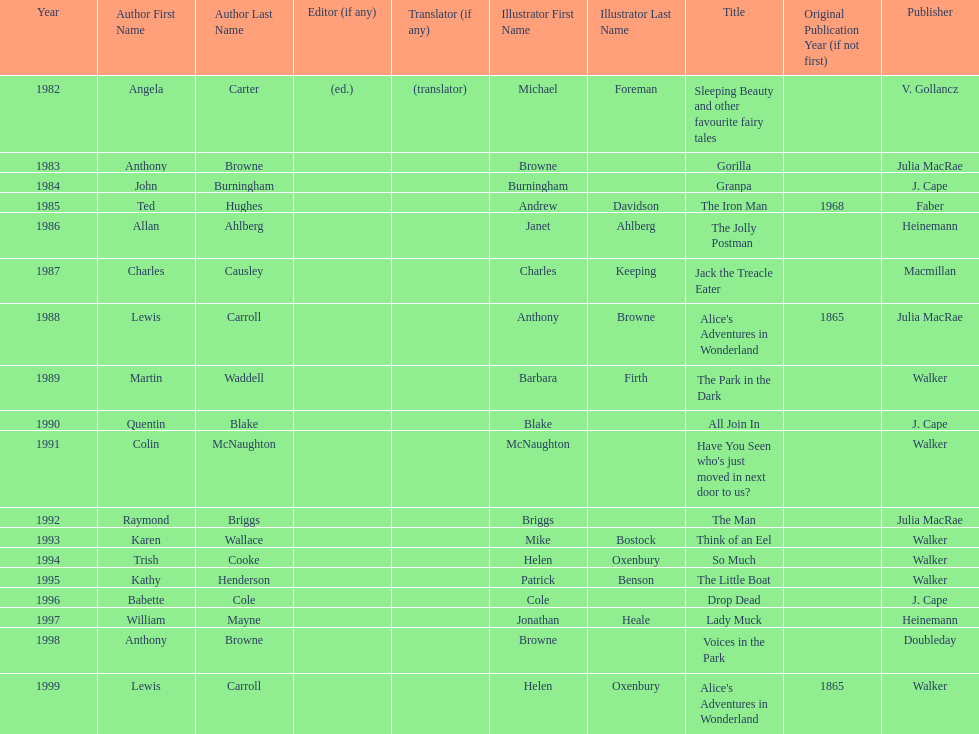What are the number of kurt maschler awards helen oxenbury has won? 2. 